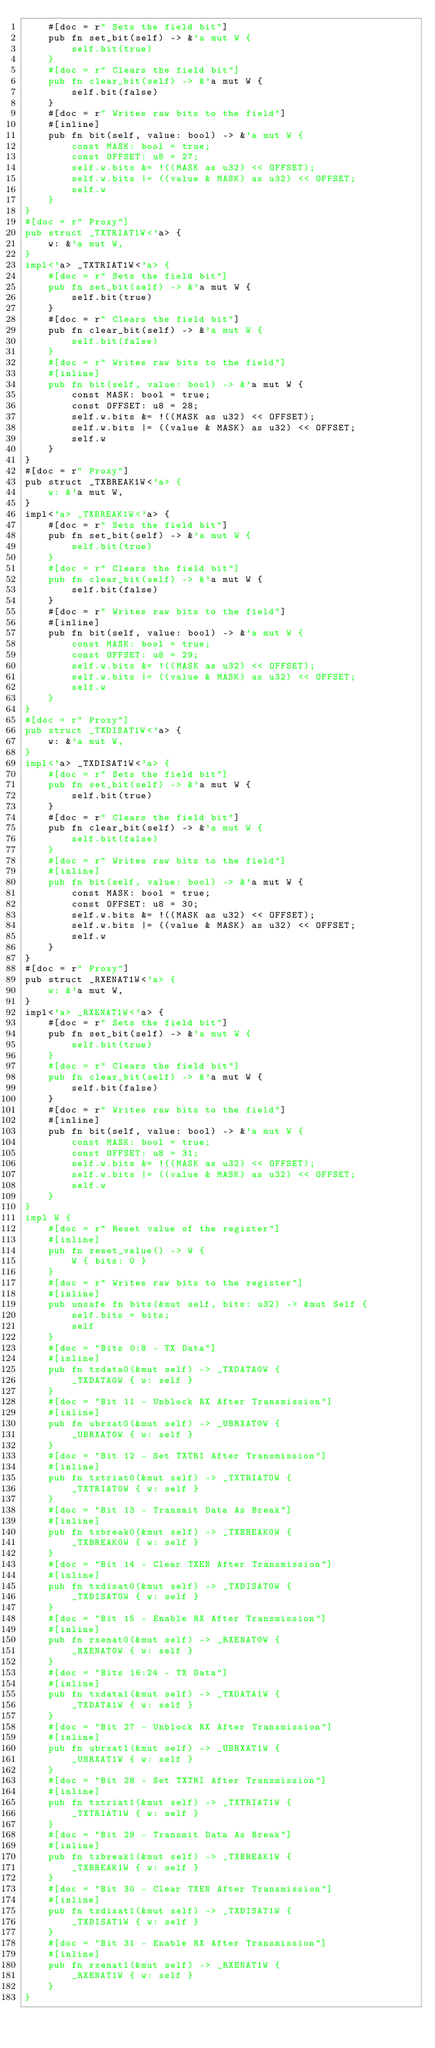Convert code to text. <code><loc_0><loc_0><loc_500><loc_500><_Rust_>    #[doc = r" Sets the field bit"]
    pub fn set_bit(self) -> &'a mut W {
        self.bit(true)
    }
    #[doc = r" Clears the field bit"]
    pub fn clear_bit(self) -> &'a mut W {
        self.bit(false)
    }
    #[doc = r" Writes raw bits to the field"]
    #[inline]
    pub fn bit(self, value: bool) -> &'a mut W {
        const MASK: bool = true;
        const OFFSET: u8 = 27;
        self.w.bits &= !((MASK as u32) << OFFSET);
        self.w.bits |= ((value & MASK) as u32) << OFFSET;
        self.w
    }
}
#[doc = r" Proxy"]
pub struct _TXTRIAT1W<'a> {
    w: &'a mut W,
}
impl<'a> _TXTRIAT1W<'a> {
    #[doc = r" Sets the field bit"]
    pub fn set_bit(self) -> &'a mut W {
        self.bit(true)
    }
    #[doc = r" Clears the field bit"]
    pub fn clear_bit(self) -> &'a mut W {
        self.bit(false)
    }
    #[doc = r" Writes raw bits to the field"]
    #[inline]
    pub fn bit(self, value: bool) -> &'a mut W {
        const MASK: bool = true;
        const OFFSET: u8 = 28;
        self.w.bits &= !((MASK as u32) << OFFSET);
        self.w.bits |= ((value & MASK) as u32) << OFFSET;
        self.w
    }
}
#[doc = r" Proxy"]
pub struct _TXBREAK1W<'a> {
    w: &'a mut W,
}
impl<'a> _TXBREAK1W<'a> {
    #[doc = r" Sets the field bit"]
    pub fn set_bit(self) -> &'a mut W {
        self.bit(true)
    }
    #[doc = r" Clears the field bit"]
    pub fn clear_bit(self) -> &'a mut W {
        self.bit(false)
    }
    #[doc = r" Writes raw bits to the field"]
    #[inline]
    pub fn bit(self, value: bool) -> &'a mut W {
        const MASK: bool = true;
        const OFFSET: u8 = 29;
        self.w.bits &= !((MASK as u32) << OFFSET);
        self.w.bits |= ((value & MASK) as u32) << OFFSET;
        self.w
    }
}
#[doc = r" Proxy"]
pub struct _TXDISAT1W<'a> {
    w: &'a mut W,
}
impl<'a> _TXDISAT1W<'a> {
    #[doc = r" Sets the field bit"]
    pub fn set_bit(self) -> &'a mut W {
        self.bit(true)
    }
    #[doc = r" Clears the field bit"]
    pub fn clear_bit(self) -> &'a mut W {
        self.bit(false)
    }
    #[doc = r" Writes raw bits to the field"]
    #[inline]
    pub fn bit(self, value: bool) -> &'a mut W {
        const MASK: bool = true;
        const OFFSET: u8 = 30;
        self.w.bits &= !((MASK as u32) << OFFSET);
        self.w.bits |= ((value & MASK) as u32) << OFFSET;
        self.w
    }
}
#[doc = r" Proxy"]
pub struct _RXENAT1W<'a> {
    w: &'a mut W,
}
impl<'a> _RXENAT1W<'a> {
    #[doc = r" Sets the field bit"]
    pub fn set_bit(self) -> &'a mut W {
        self.bit(true)
    }
    #[doc = r" Clears the field bit"]
    pub fn clear_bit(self) -> &'a mut W {
        self.bit(false)
    }
    #[doc = r" Writes raw bits to the field"]
    #[inline]
    pub fn bit(self, value: bool) -> &'a mut W {
        const MASK: bool = true;
        const OFFSET: u8 = 31;
        self.w.bits &= !((MASK as u32) << OFFSET);
        self.w.bits |= ((value & MASK) as u32) << OFFSET;
        self.w
    }
}
impl W {
    #[doc = r" Reset value of the register"]
    #[inline]
    pub fn reset_value() -> W {
        W { bits: 0 }
    }
    #[doc = r" Writes raw bits to the register"]
    #[inline]
    pub unsafe fn bits(&mut self, bits: u32) -> &mut Self {
        self.bits = bits;
        self
    }
    #[doc = "Bits 0:8 - TX Data"]
    #[inline]
    pub fn txdata0(&mut self) -> _TXDATA0W {
        _TXDATA0W { w: self }
    }
    #[doc = "Bit 11 - Unblock RX After Transmission"]
    #[inline]
    pub fn ubrxat0(&mut self) -> _UBRXAT0W {
        _UBRXAT0W { w: self }
    }
    #[doc = "Bit 12 - Set TXTRI After Transmission"]
    #[inline]
    pub fn txtriat0(&mut self) -> _TXTRIAT0W {
        _TXTRIAT0W { w: self }
    }
    #[doc = "Bit 13 - Transmit Data As Break"]
    #[inline]
    pub fn txbreak0(&mut self) -> _TXBREAK0W {
        _TXBREAK0W { w: self }
    }
    #[doc = "Bit 14 - Clear TXEN After Transmission"]
    #[inline]
    pub fn txdisat0(&mut self) -> _TXDISAT0W {
        _TXDISAT0W { w: self }
    }
    #[doc = "Bit 15 - Enable RX After Transmission"]
    #[inline]
    pub fn rxenat0(&mut self) -> _RXENAT0W {
        _RXENAT0W { w: self }
    }
    #[doc = "Bits 16:24 - TX Data"]
    #[inline]
    pub fn txdata1(&mut self) -> _TXDATA1W {
        _TXDATA1W { w: self }
    }
    #[doc = "Bit 27 - Unblock RX After Transmission"]
    #[inline]
    pub fn ubrxat1(&mut self) -> _UBRXAT1W {
        _UBRXAT1W { w: self }
    }
    #[doc = "Bit 28 - Set TXTRI After Transmission"]
    #[inline]
    pub fn txtriat1(&mut self) -> _TXTRIAT1W {
        _TXTRIAT1W { w: self }
    }
    #[doc = "Bit 29 - Transmit Data As Break"]
    #[inline]
    pub fn txbreak1(&mut self) -> _TXBREAK1W {
        _TXBREAK1W { w: self }
    }
    #[doc = "Bit 30 - Clear TXEN After Transmission"]
    #[inline]
    pub fn txdisat1(&mut self) -> _TXDISAT1W {
        _TXDISAT1W { w: self }
    }
    #[doc = "Bit 31 - Enable RX After Transmission"]
    #[inline]
    pub fn rxenat1(&mut self) -> _RXENAT1W {
        _RXENAT1W { w: self }
    }
}
</code> 